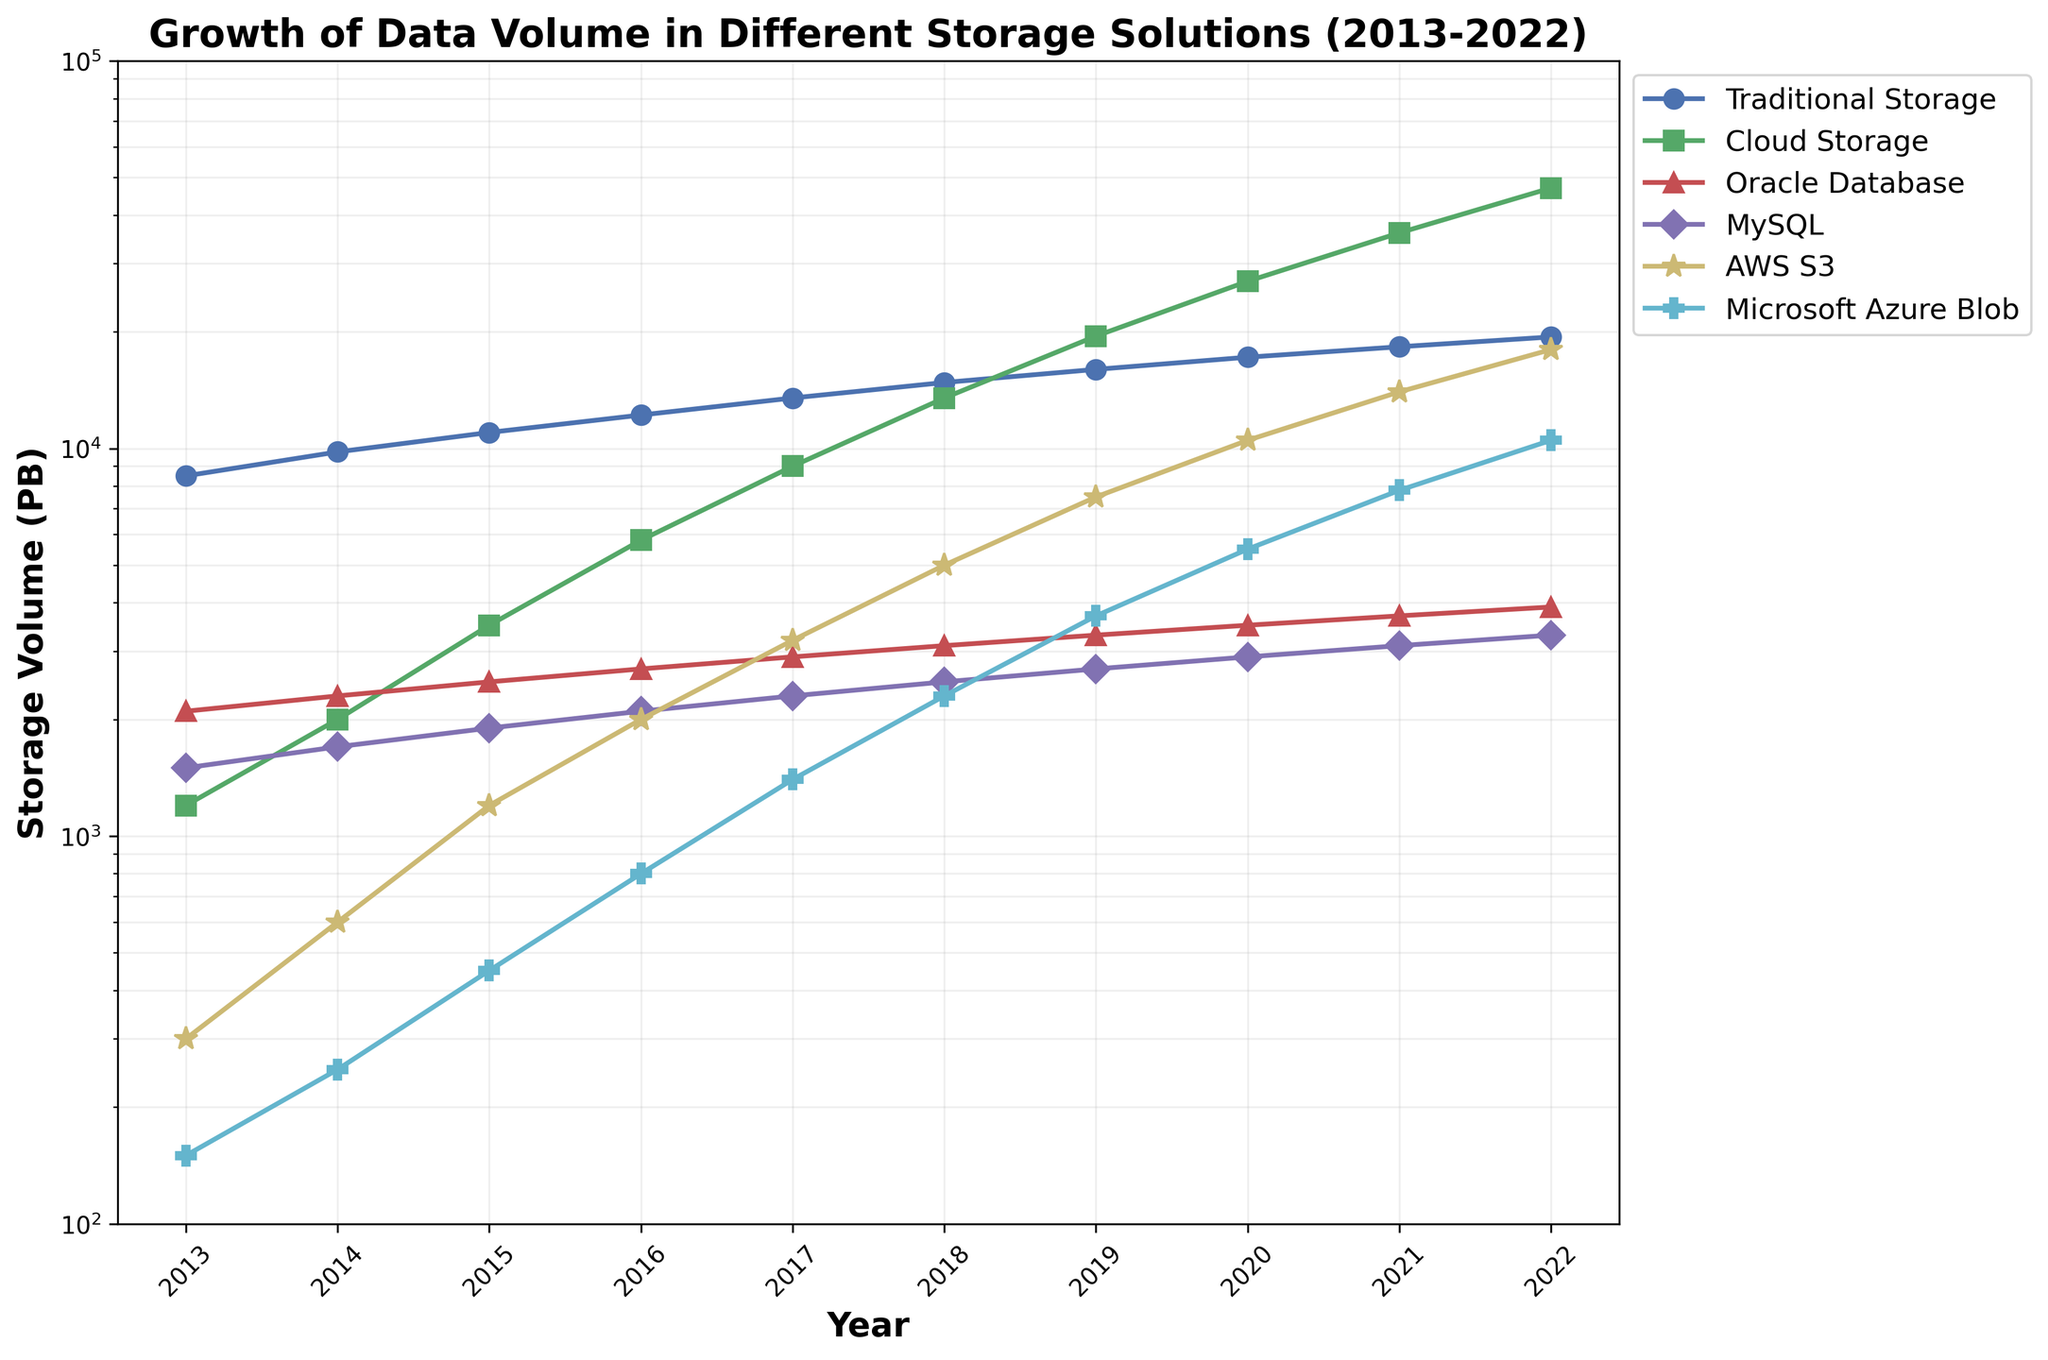Which year had the highest data volume in traditional storage? Look for the year where the traditional storage line reaches its highest point. According to the figure, the highest point is in 2022.
Answer: 2022 How does the volume of cloud storage in 2017 compare to traditional storage in the same year? Observe the data volume for both cloud storage and traditional storage in 2017. Cloud storage is 9000 PB, whereas traditional storage is 13500 PB.
Answer: Traditional storage is higher than cloud storage in 2017 What is the trend of AWS S3 storage from 2013 to 2022? Follow the AWS S3 line from 2013 to 2022. Notice the trend showing an increase every year, reaching significantly higher values towards 2022.
Answer: Increasing trend Which storage solution had the largest growth between 2013 and 2022? Calculate the difference in storage volume for each storage solution between 2013 and 2022. Compare these differences: Traditional (19400-8500), Cloud (47000-1200), Oracle (3900-2100), MySQL (3300-1500), AWS S3 (18000-300), Azure (10500-150). The largest growth is cloud storage.
Answer: Cloud Storage How many petabytes more cloud storage was used in 2020 compared to 2015? Find the data values for cloud storage in 2020 and 2015, and calculate the difference: 27000 - 3500.
Answer: 23500 PB Between 2019 and 2020, which storage solution showed the greatest increase in volume? Calculate the year-over-year increase for each storage solution between 2019 and 2020: Traditional (17200-16000), Cloud (27000-19500), Oracle (3500-3300), MySQL (2900-2700), AWS S3 (10500-7500), Azure (5500-3700). Determine the highest increase, which is cloud storage.
Answer: Cloud Storage What visual cue indicates the use of exponential growth scaling on the y-axis? The y-axis uses a logarithmic scale, indicated by the progressively increasing intervals (e.g., 100, 1000, 10000).
Answer: Logarithmic scale Which storage solution had the steepest growth curve between 2018 and 2022? Observe the gradients of the lines from 2018 to 2022. The steepest line indicates the most significant growth rate. Cloud storage appears to have the steepest curve during this period.
Answer: Cloud Storage How did the data volume for Microsoft Azure Blob change from 2016 to 2019? Track the Microsoft Azure Blob line from 2016 to 2019. The data volume increased from 800 PB in 2016 to 3700 PB in 2019.
Answer: Increased In which year did MySQL storage volume surpass Oracle Database storage volume? Compare the MySQL and Oracle Database lines over the years. Identify the year when the MySQL line goes above the Oracle Database line, which is in 2022.
Answer: 2022 